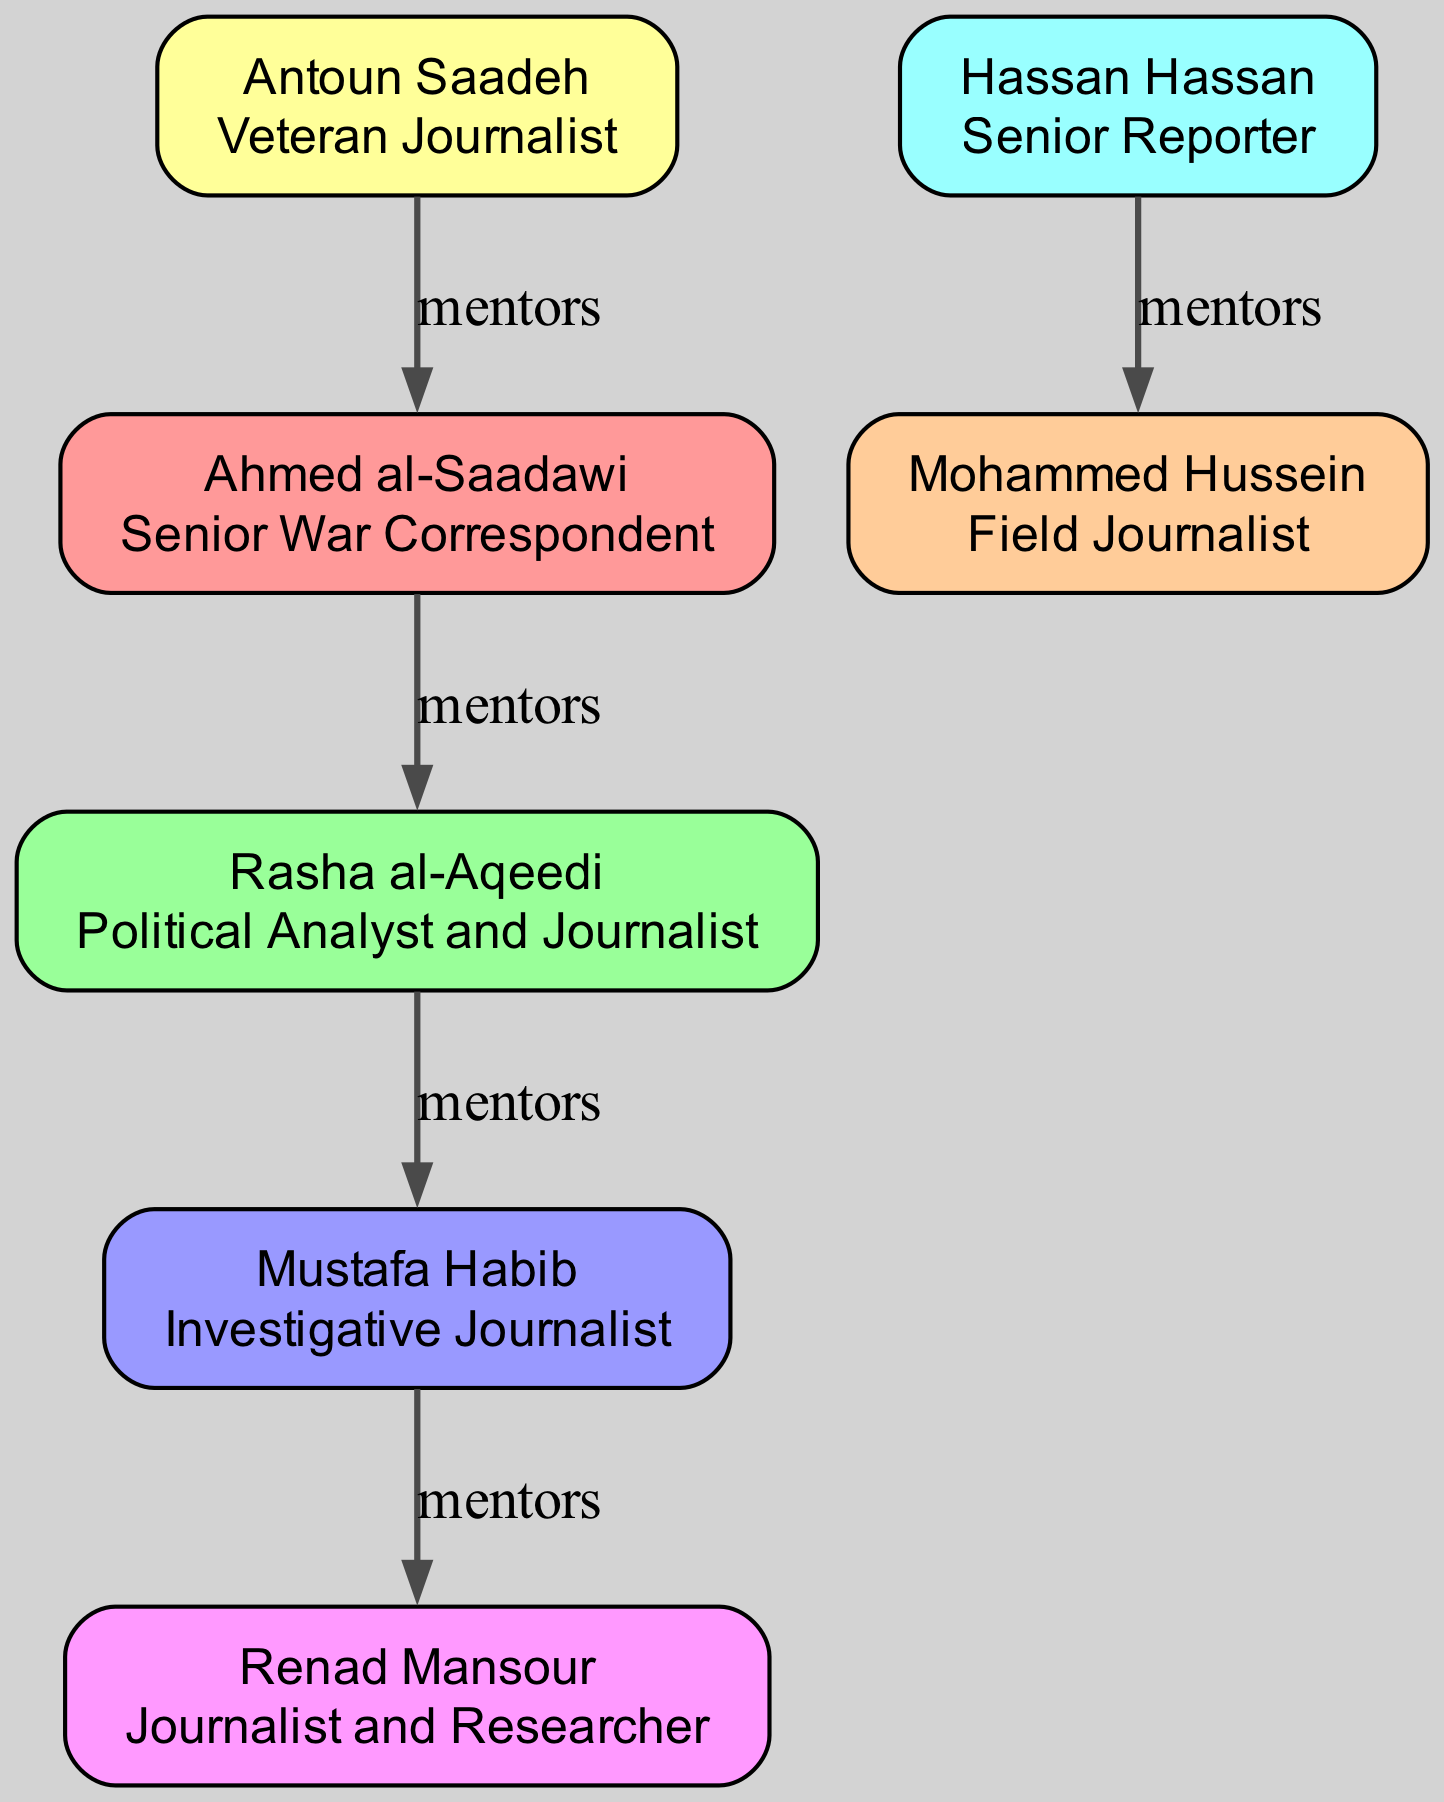What is the role of Ahmed al-Saadawi? The diagram indicates that Ahmed al-Saadawi's role is a Senior War Correspondent, which is clearly listed next to his name.
Answer: Senior War Correspondent Who mentored Renad Mansour? By examining the diagram, it can be seen that Renad Mansour was mentored by Mustafa Habib, as indicated by the arrows connecting their nodes.
Answer: Mustafa Habib How many journalists are shown in the diagram? Counting the nodes in the diagram reveals a total of six journalists, each represented as a unique node.
Answer: 6 What relationship does Rasha al-Aqeedi have with Ahmed al-Saadawi? The diagram shows a direct mentorship connection from Ahmed al-Saadawi to Rasha al-Aqeedi, indicating that Rasha was mentored by Ahmed.
Answer: Mentor-Mentee Which journalist is the mentor of Mohammed Hussein? The diagram clearly states that Hassan Hassan is the mentor of Mohammed Hussein through the connection displayed.
Answer: Hassan Hassan Who is the most senior mentor in the lineage? By tracing the mentorship back to the earliest connection, Antoun Saadeh is identified as the most senior mentor, having mentored Ahmed al-Saadawi.
Answer: Antoun Saadeh Which role is associated with Rasha al-Aqeedi? In the diagram, Rasha al-Aqeedi's role is designated as a Political Analyst and Journalist, which is depicted next to her name.
Answer: Political Analyst and Journalist How many direct mentorship relationships are depicted? The diagram highlights five distinct mentorship relationships through connecting lines between mentor and mentee nodes.
Answer: 5 What is the role of Mohammed Hussein? Upon examining the node dedicated to Mohammed Hussein, it is evident that his role is labeled as Field Journalist.
Answer: Field Journalist 